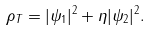Convert formula to latex. <formula><loc_0><loc_0><loc_500><loc_500>\rho _ { T } = | \psi _ { 1 } | ^ { 2 } + \eta | \psi _ { 2 } | ^ { 2 } .</formula> 